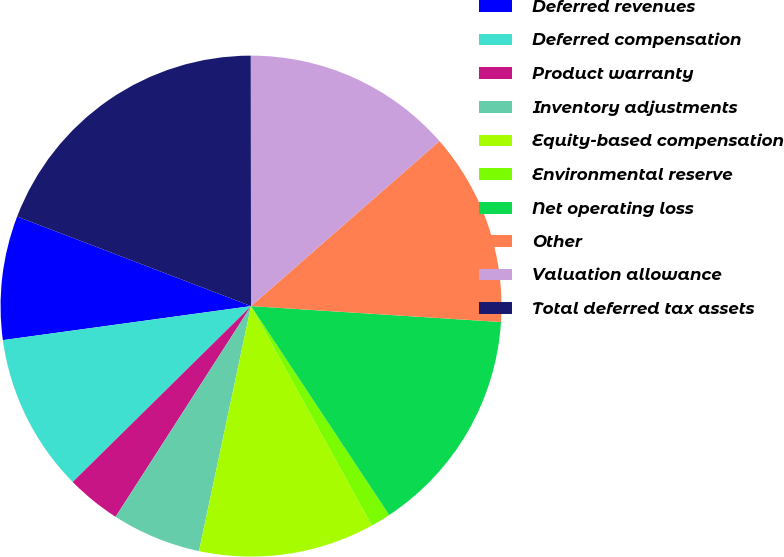Convert chart. <chart><loc_0><loc_0><loc_500><loc_500><pie_chart><fcel>Deferred revenues<fcel>Deferred compensation<fcel>Product warranty<fcel>Inventory adjustments<fcel>Equity-based compensation<fcel>Environmental reserve<fcel>Net operating loss<fcel>Other<fcel>Valuation allowance<fcel>Total deferred tax assets<nl><fcel>7.99%<fcel>10.22%<fcel>3.52%<fcel>5.76%<fcel>11.34%<fcel>1.29%<fcel>14.69%<fcel>12.46%<fcel>13.57%<fcel>19.16%<nl></chart> 